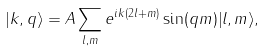Convert formula to latex. <formula><loc_0><loc_0><loc_500><loc_500>| { k , q } \rangle = A \sum _ { l , m } e ^ { i k ( 2 l + m ) } \sin ( q m ) | { l , m } \rangle ,</formula> 